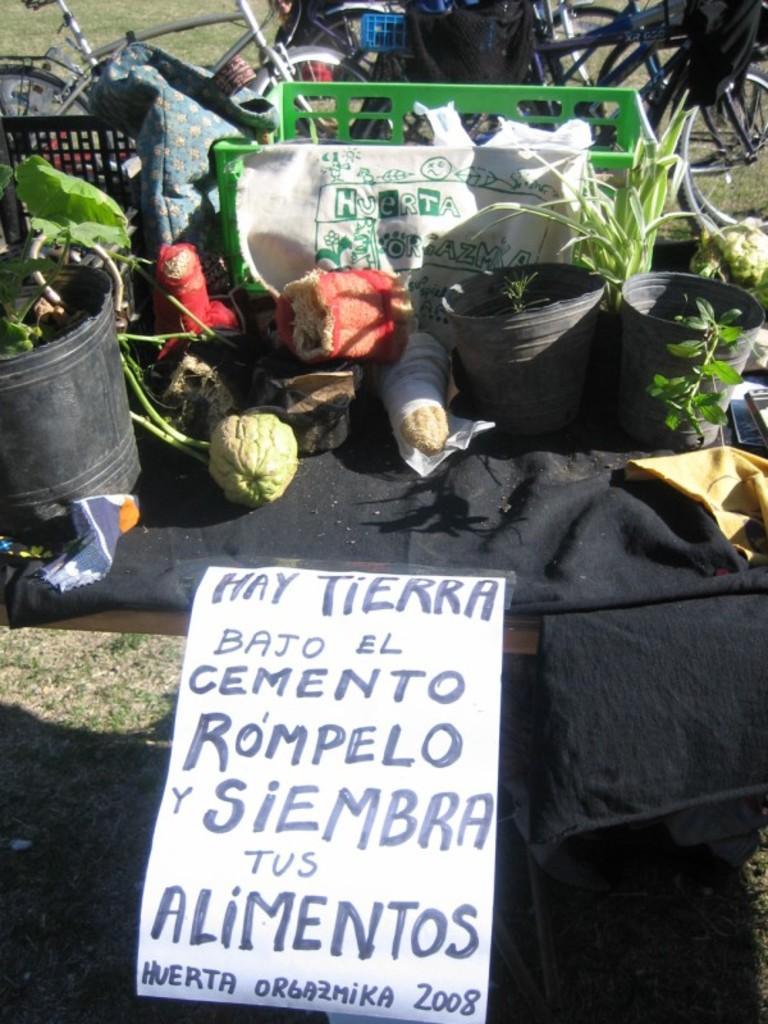In one or two sentences, can you explain what this image depicts? In this image we can see pots, vegetables, carry bags, plastic container, bicycles, black color cloth and one poster on the grassy land. 